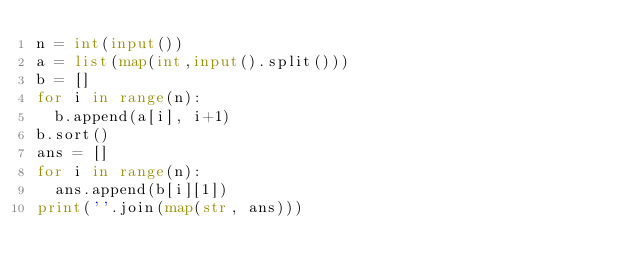<code> <loc_0><loc_0><loc_500><loc_500><_Python_>n = int(input())
a = list(map(int,input().split()))
b = []
for i in range(n):
  b.append(a[i], i+1)
b.sort()
ans = []
for i in range(n):
  ans.append(b[i][1])
print(''.join(map(str, ans)))</code> 